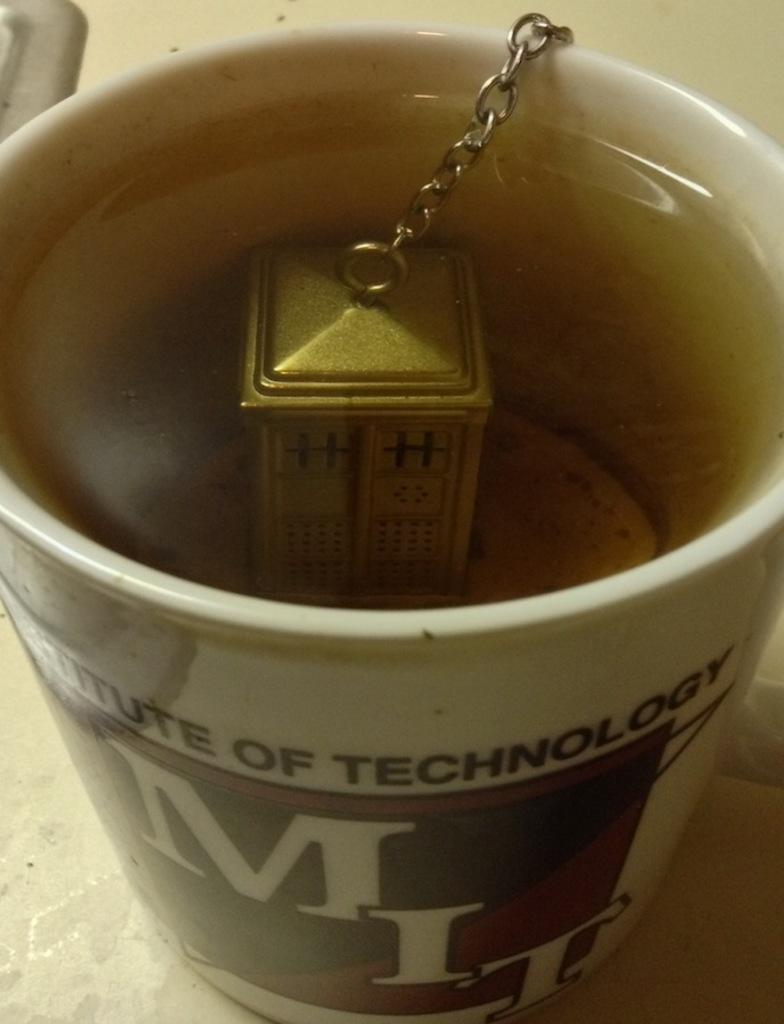<image>
Create a compact narrative representing the image presented. A ceramic mug says Insitute of Technology MIT on the front. 